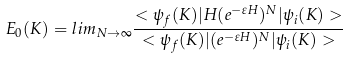<formula> <loc_0><loc_0><loc_500><loc_500>E _ { 0 } ( K ) = l i m _ { N \rightarrow \infty } \frac { < \psi _ { f } ( K ) | H ( e ^ { - \varepsilon H } ) ^ { N } | \psi _ { i } ( K ) > } { < \psi _ { f } ( K ) | ( e ^ { - \varepsilon H } ) ^ { N } | \psi _ { i } ( K ) > }</formula> 